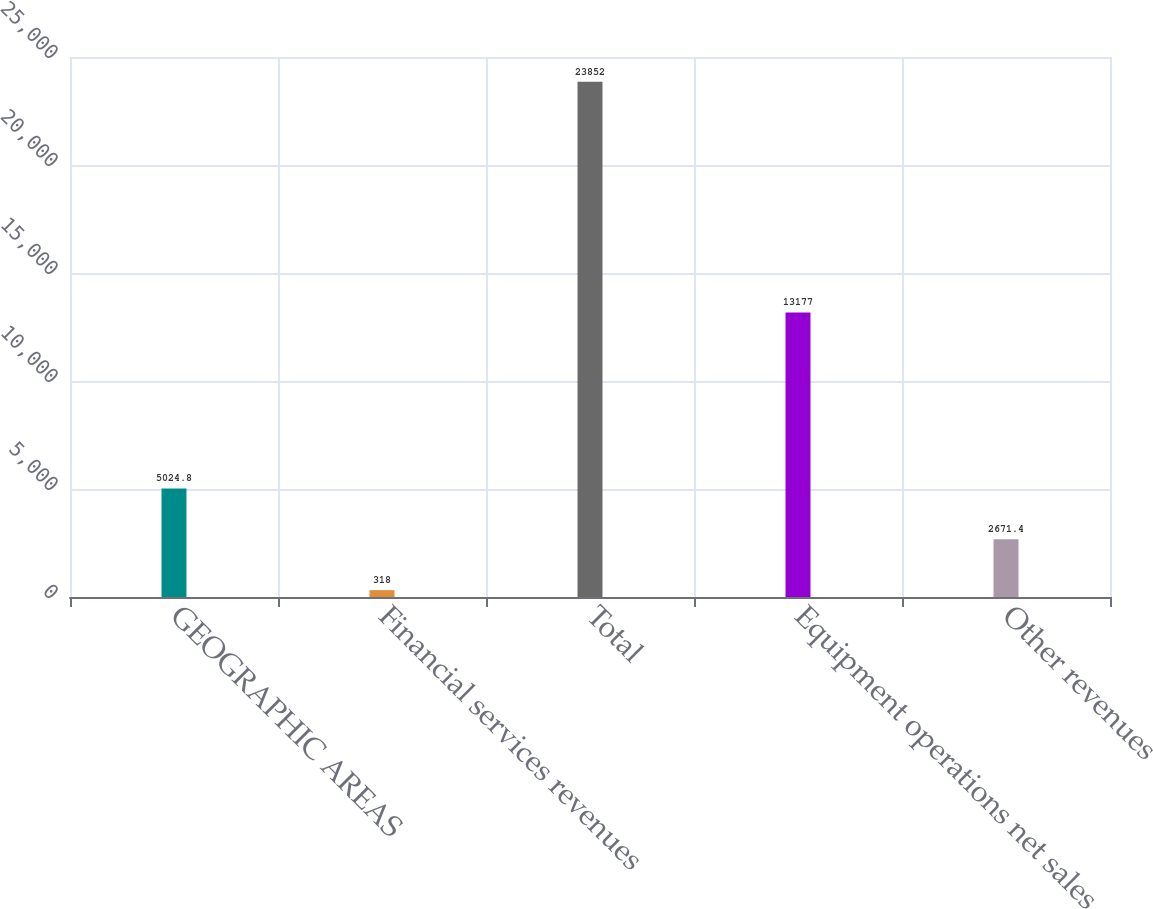Convert chart to OTSL. <chart><loc_0><loc_0><loc_500><loc_500><bar_chart><fcel>GEOGRAPHIC AREAS<fcel>Financial services revenues<fcel>Total<fcel>Equipment operations net sales<fcel>Other revenues<nl><fcel>5024.8<fcel>318<fcel>23852<fcel>13177<fcel>2671.4<nl></chart> 